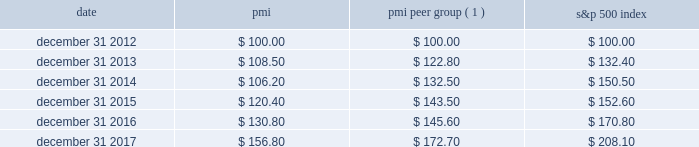Performance graph the graph below compares the cumulative total shareholder return on pmi's common stock with the cumulative total return for the same period of pmi's peer group and the s&p 500 index .
The graph assumes the investment of $ 100 as of december 31 , 2012 , in pmi common stock ( at prices quoted on the new york stock exchange ) and each of the indices as of the market close and reinvestment of dividends on a quarterly basis .
Date pmi pmi peer group ( 1 ) s&p 500 index .
( 1 ) the pmi peer group presented in this graph is the same as that used in the prior year , except reynolds american inc .
Was removed following the completion of its acquisition by british american tobacco p.l.c .
On july 25 , 2017 .
The pmi peer group was established based on a review of four characteristics : global presence ; a focus on consumer products ; and net revenues and a market capitalization of a similar size to those of pmi .
The review also considered the primary international tobacco companies .
As a result of this review , the following companies constitute the pmi peer group : altria group , inc. , anheuser-busch inbev sa/nv , british american tobacco p.l.c. , the coca-cola company , colgate-palmolive co. , diageo plc , heineken n.v. , imperial brands plc , japan tobacco inc. , johnson & johnson , kimberly-clark corporation , the kraft-heinz company , mcdonald's corp. , mondel z international , inc. , nestl e9 s.a. , pepsico , inc. , the procter & gamble company , roche holding ag , and unilever nv and plc .
Note : figures are rounded to the nearest $ 0.10. .
What was the difference in percentage cumulative total shareholder return on pmi's common stock versus the s&p 500 index for the five years ended december 31 , 2017? 
Computations: (((156.80 - 100) / 100) - ((208.10 - 100) / 100))
Answer: -0.513. Performance graph the graph below compares the cumulative total shareholder return on pmi's common stock with the cumulative total return for the same period of pmi's peer group and the s&p 500 index .
The graph assumes the investment of $ 100 as of december 31 , 2012 , in pmi common stock ( at prices quoted on the new york stock exchange ) and each of the indices as of the market close and reinvestment of dividends on a quarterly basis .
Date pmi pmi peer group ( 1 ) s&p 500 index .
( 1 ) the pmi peer group presented in this graph is the same as that used in the prior year , except reynolds american inc .
Was removed following the completion of its acquisition by british american tobacco p.l.c .
On july 25 , 2017 .
The pmi peer group was established based on a review of four characteristics : global presence ; a focus on consumer products ; and net revenues and a market capitalization of a similar size to those of pmi .
The review also considered the primary international tobacco companies .
As a result of this review , the following companies constitute the pmi peer group : altria group , inc. , anheuser-busch inbev sa/nv , british american tobacco p.l.c. , the coca-cola company , colgate-palmolive co. , diageo plc , heineken n.v. , imperial brands plc , japan tobacco inc. , johnson & johnson , kimberly-clark corporation , the kraft-heinz company , mcdonald's corp. , mondel z international , inc. , nestl e9 s.a. , pepsico , inc. , the procter & gamble company , roche holding ag , and unilever nv and plc .
Note : figures are rounded to the nearest $ 0.10. .
What was the percentage cumulative total shareholder return on pmi's common stock for the five years ended december 31 , 2017? 
Computations: ((156.80 - 100) / 100)
Answer: 0.568. 